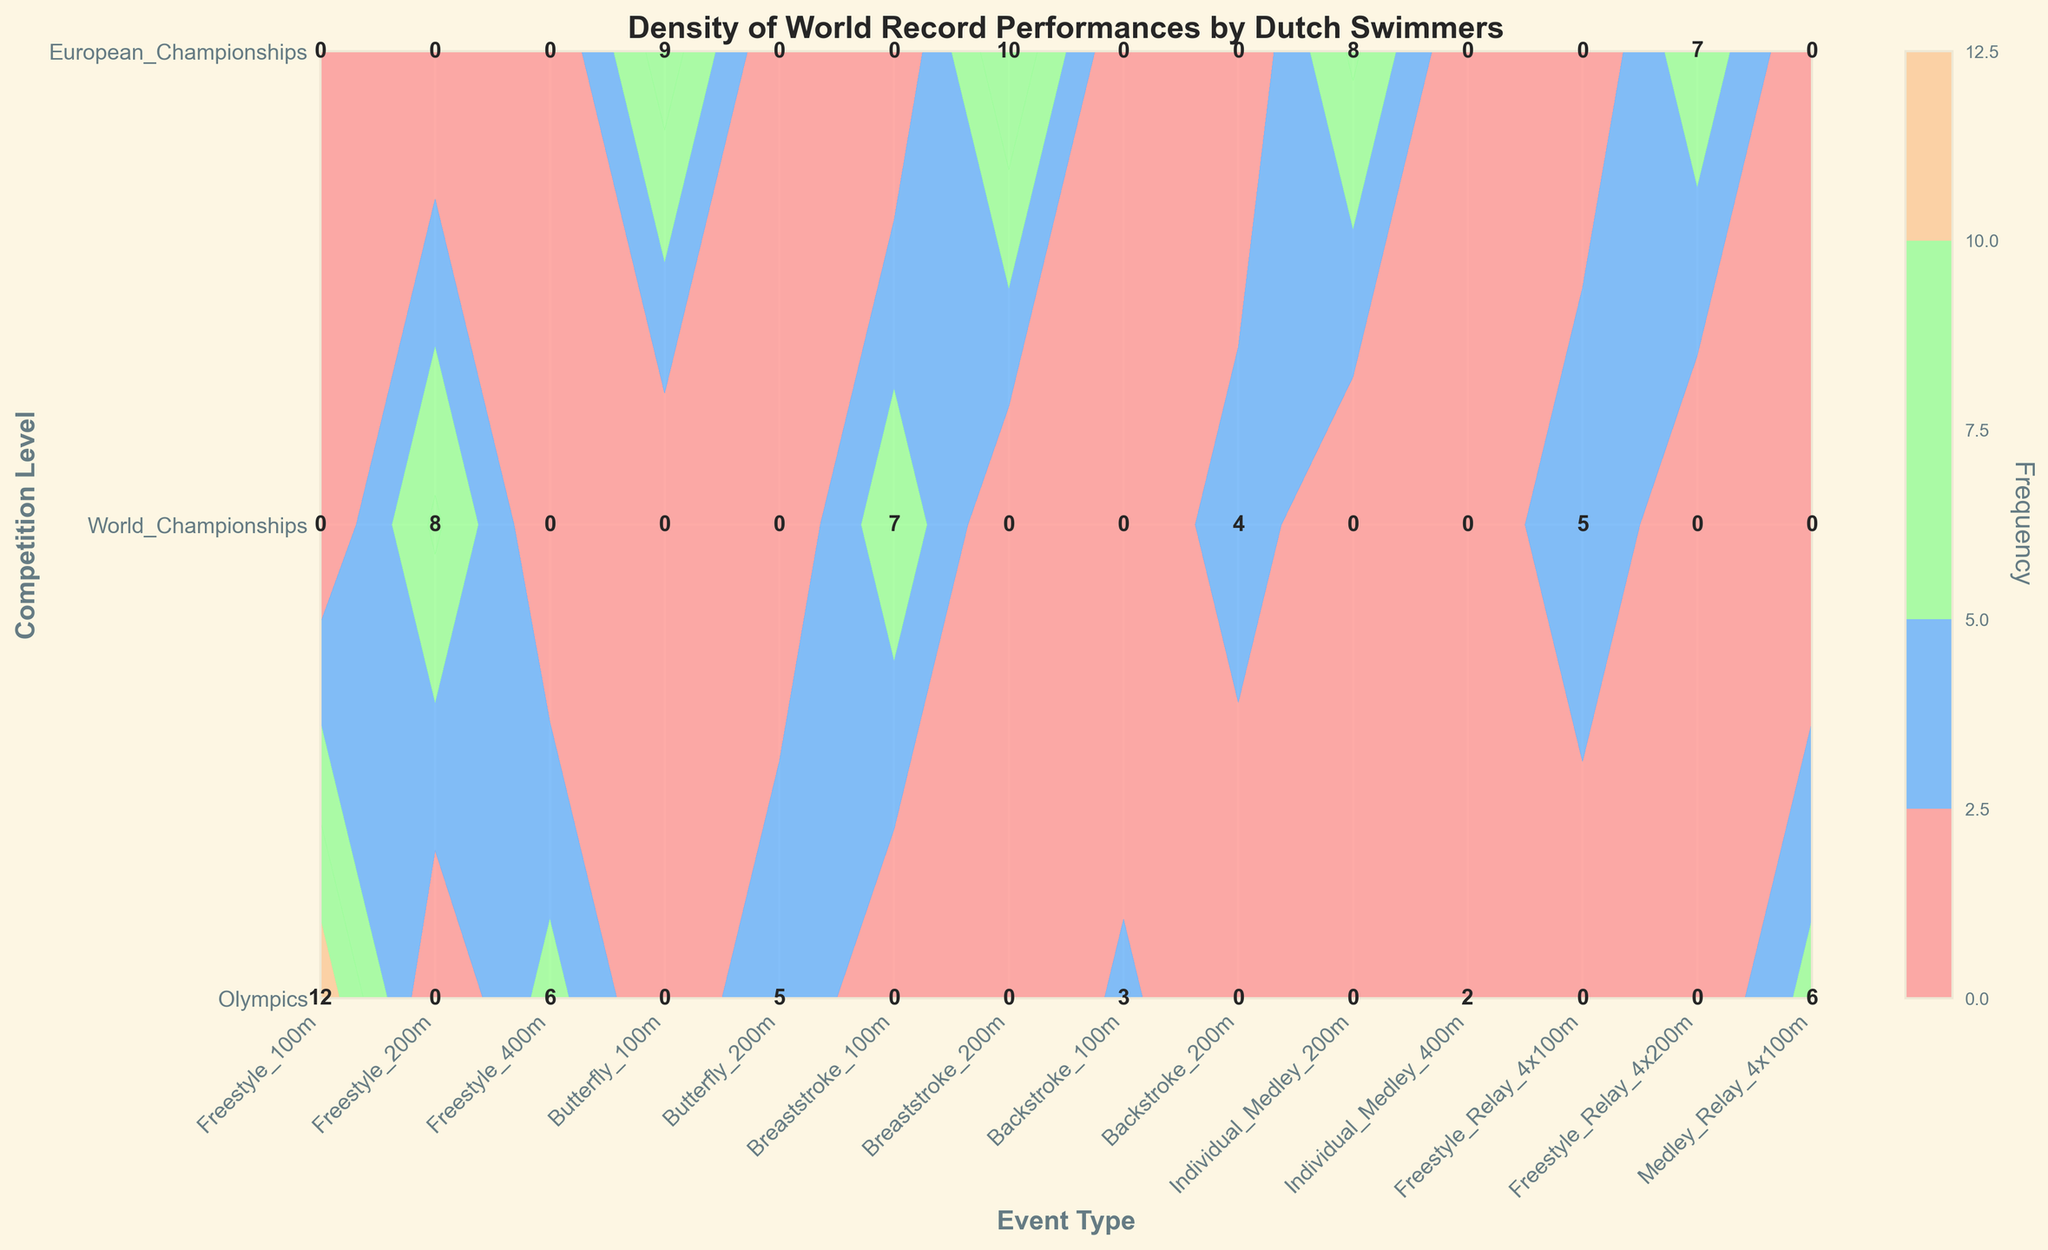Which event type has the highest frequency of world record performances by Dutch swimmers in the Olympics? The plot shows different frequencies for each event type within the Olympics competition level. The top frequency for the Olympics is the Freestyle 100m with 12 records.
Answer: Freestyle 100m Which competition level features the highest frequency of world record performances in the Freestyle 200m event? The plot shows the frequency of the Freestyle 200m event across different competition levels. The highest frequency for Freestyle 200m is in the World Championships with 8 records.
Answer: World Championships What is the cumulative frequency of world record performances by Dutch swimmers in all Freestyle events across all competition levels? Adding the frequencies for Freestyle 100m (12 Olympics), Freestyle 200m (8 World Championships), Freestyle 400m (6 Olympics), Freestyle Relay 4x100m (5 World Championships), and Freestyle Relay 4x200m (7 European Championships): 12 + 8 + 6 + 5 + 7 = 38.
Answer: 38 Which competition level has the most even distribution of world record performances across different event types? By looking at the labels for each competition level, the European Championships show reasonable frequencies for various event types without extreme values, suggesting an even distribution.
Answer: European Championships Which single event type shows the lowest frequency of world record performances, and what is its frequency? The plot shows labels for all event types and frequencies. Backstroke 100m at the Olympics has the lowest frequency with just 3 records.
Answer: Backstroke 100m, 3 